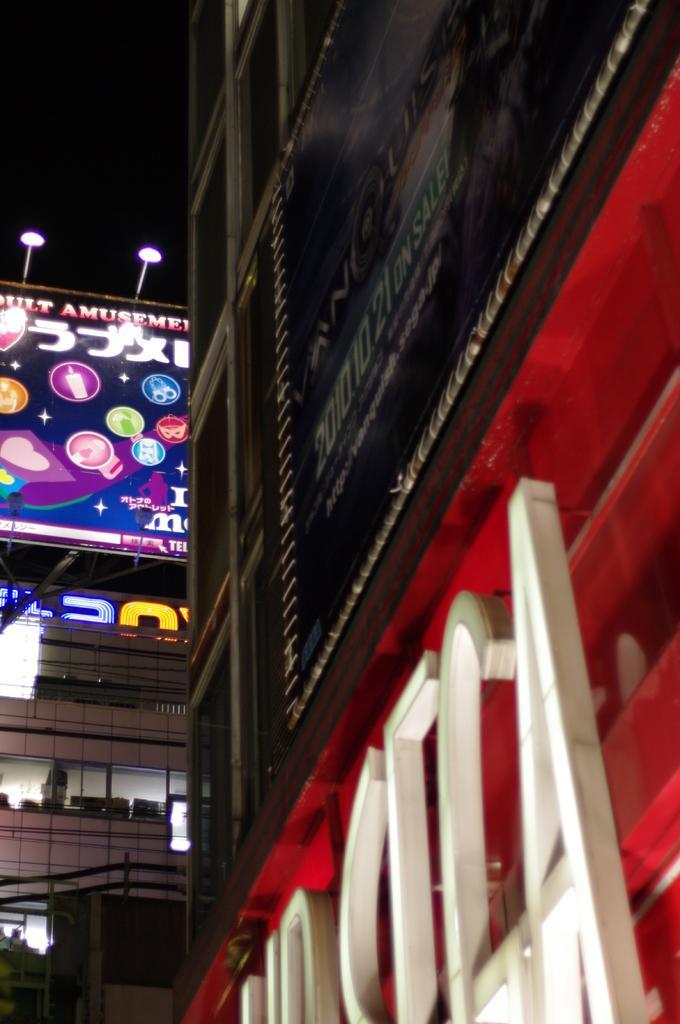Could you give a brief overview of what you see in this image? In this image we can see building, advertisement, lights and sky. 